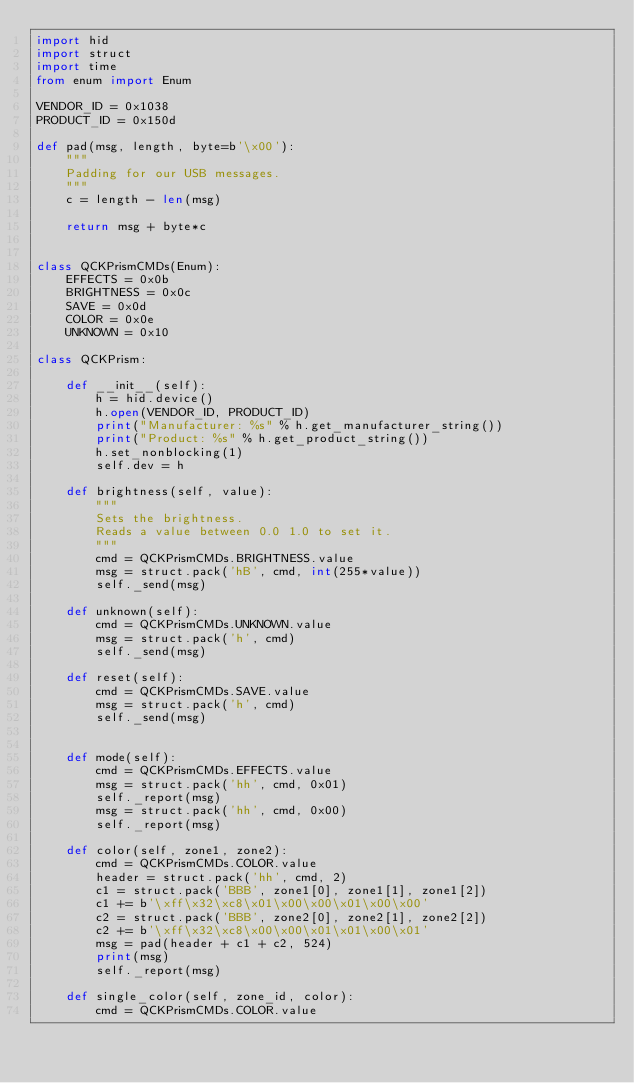Convert code to text. <code><loc_0><loc_0><loc_500><loc_500><_Python_>import hid
import struct
import time
from enum import Enum

VENDOR_ID = 0x1038
PRODUCT_ID = 0x150d

def pad(msg, length, byte=b'\x00'):
    """
    Padding for our USB messages.
    """
    c = length - len(msg)

    return msg + byte*c


class QCKPrismCMDs(Enum):
    EFFECTS = 0x0b
    BRIGHTNESS = 0x0c
    SAVE = 0x0d
    COLOR = 0x0e
    UNKNOWN = 0x10

class QCKPrism:

    def __init__(self):
        h = hid.device()
        h.open(VENDOR_ID, PRODUCT_ID)
        print("Manufacturer: %s" % h.get_manufacturer_string())
        print("Product: %s" % h.get_product_string())
        h.set_nonblocking(1)
        self.dev = h

    def brightness(self, value):
        """
        Sets the brightness.
        Reads a value between 0.0 1.0 to set it.
        """
        cmd = QCKPrismCMDs.BRIGHTNESS.value
        msg = struct.pack('hB', cmd, int(255*value))
        self._send(msg)

    def unknown(self):
        cmd = QCKPrismCMDs.UNKNOWN.value
        msg = struct.pack('h', cmd)
        self._send(msg)

    def reset(self):
        cmd = QCKPrismCMDs.SAVE.value
        msg = struct.pack('h', cmd)
        self._send(msg)


    def mode(self):
        cmd = QCKPrismCMDs.EFFECTS.value
        msg = struct.pack('hh', cmd, 0x01)
        self._report(msg)
        msg = struct.pack('hh', cmd, 0x00)
        self._report(msg)

    def color(self, zone1, zone2):
        cmd = QCKPrismCMDs.COLOR.value
        header = struct.pack('hh', cmd, 2)
        c1 = struct.pack('BBB', zone1[0], zone1[1], zone1[2])
        c1 += b'\xff\x32\xc8\x01\x00\x00\x01\x00\x00'
        c2 = struct.pack('BBB', zone2[0], zone2[1], zone2[2])
        c2 += b'\xff\x32\xc8\x00\x00\x01\x01\x00\x01'
        msg = pad(header + c1 + c2, 524)
        print(msg)
        self._report(msg)

    def single_color(self, zone_id, color):
        cmd = QCKPrismCMDs.COLOR.value</code> 